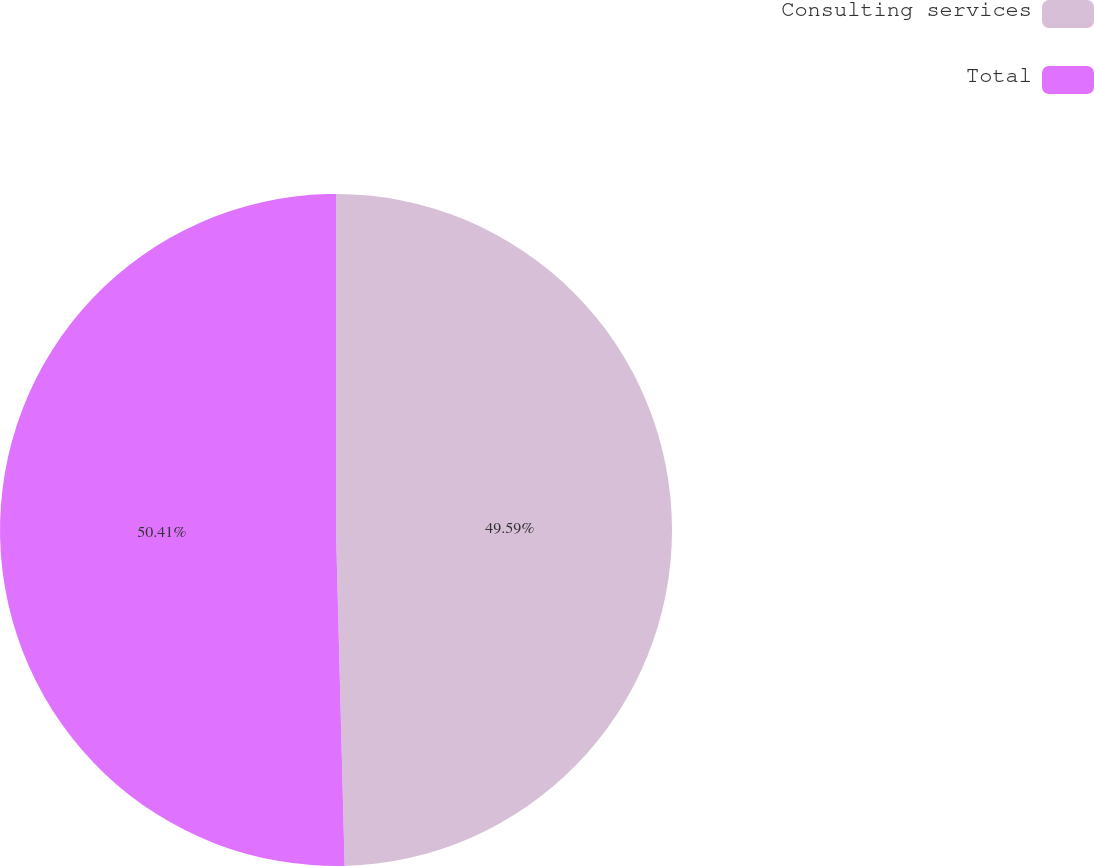Convert chart. <chart><loc_0><loc_0><loc_500><loc_500><pie_chart><fcel>Consulting services<fcel>Total<nl><fcel>49.59%<fcel>50.41%<nl></chart> 